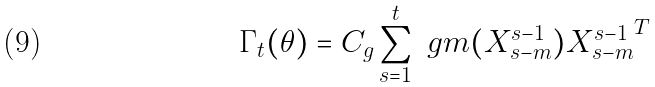<formula> <loc_0><loc_0><loc_500><loc_500>\Gamma _ { t } ( \theta ) = C _ { g } \sum _ { s = 1 } ^ { t } \ g m ( X _ { s - m } ^ { s - 1 } ) { X _ { s - m } ^ { s - 1 } } ^ { T }</formula> 